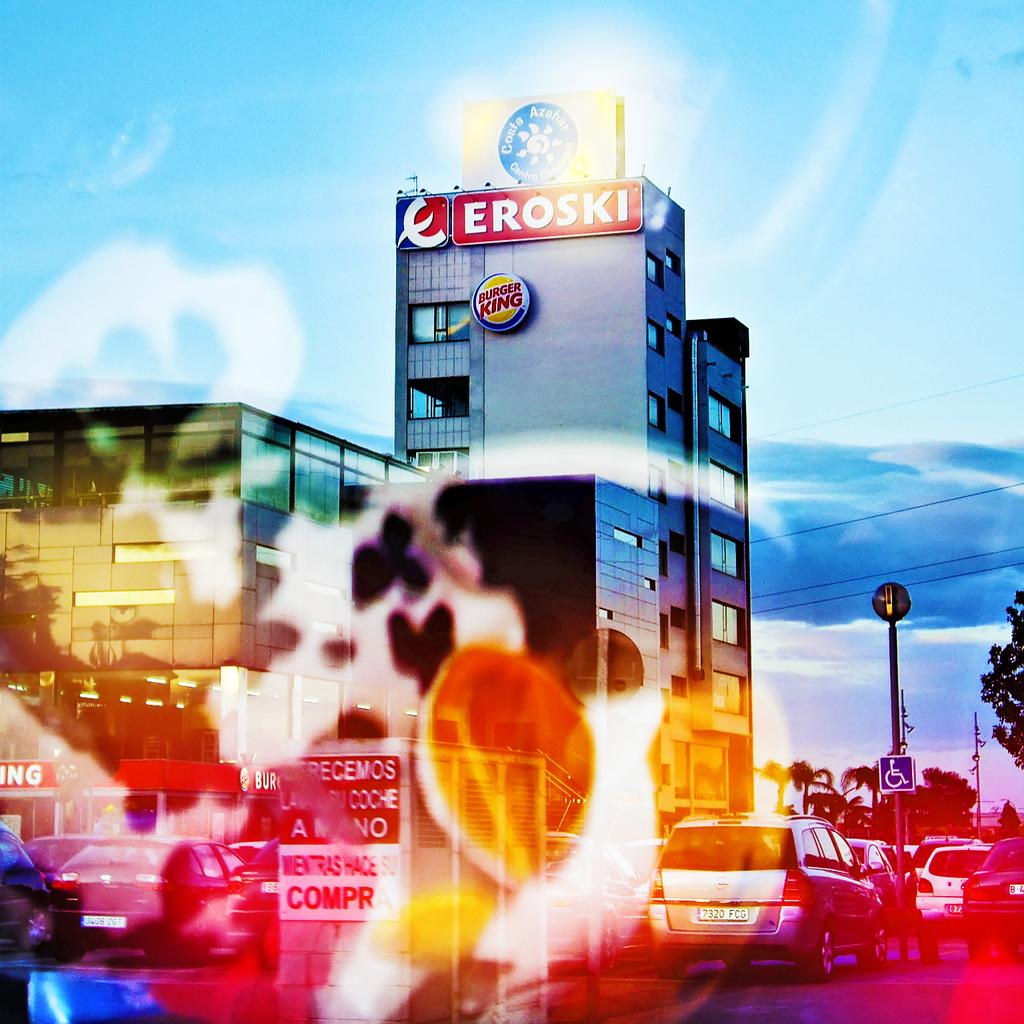What can be seen on the road in the image? There are vehicles on the road in the image. How do we know that the image has been edited? The fact that the image has been edited is mentioned, but we cannot determine the specific editing from the image itself. What is visible in the distance behind the vehicles? There are buildings, poles, clouds, and the sky visible in the background of the image. What type of offer is being made by the vehicles in the image? There is no indication in the image that the vehicles are making any offers. What day of the week is depicted in the image? The day of the week is not visible or mentioned in the image. 